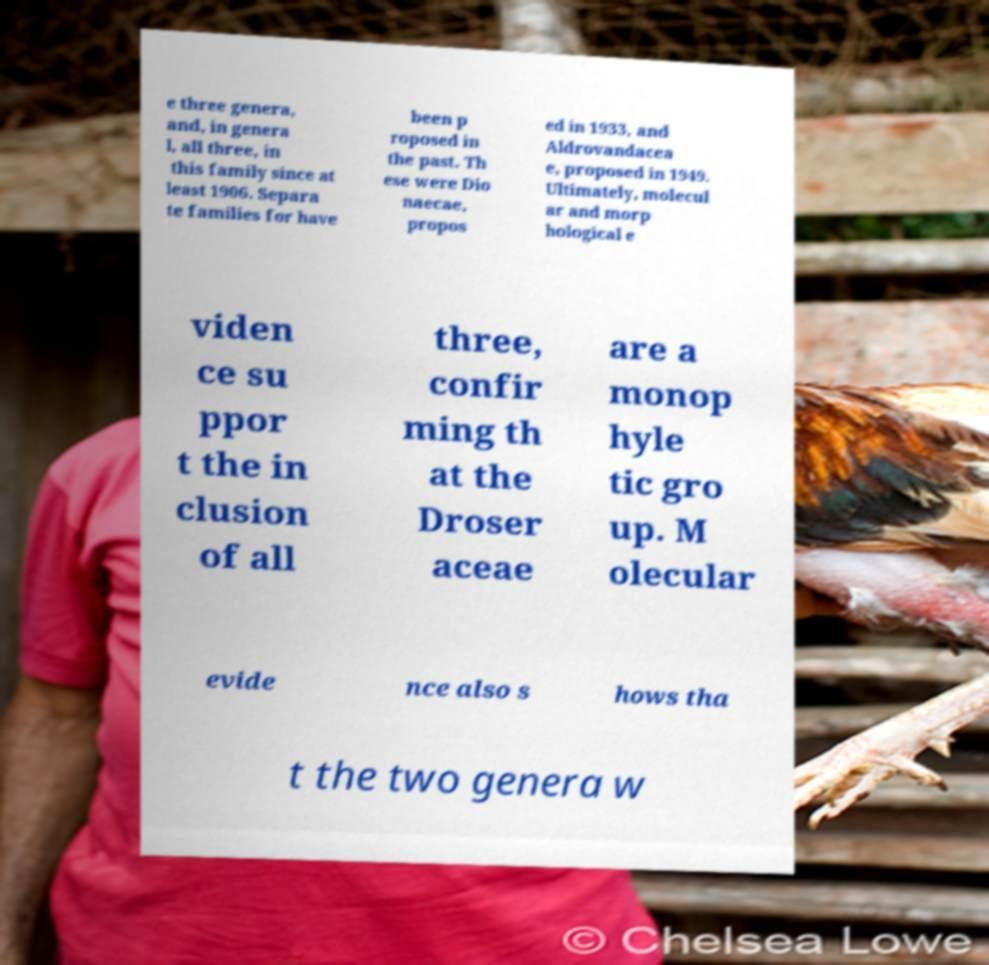Can you read and provide the text displayed in the image?This photo seems to have some interesting text. Can you extract and type it out for me? e three genera, and, in genera l, all three, in this family since at least 1906. Separa te families for have been p roposed in the past. Th ese were Dio naecae, propos ed in 1933, and Aldrovandacea e, proposed in 1949. Ultimately, molecul ar and morp hological e viden ce su ppor t the in clusion of all three, confir ming th at the Droser aceae are a monop hyle tic gro up. M olecular evide nce also s hows tha t the two genera w 